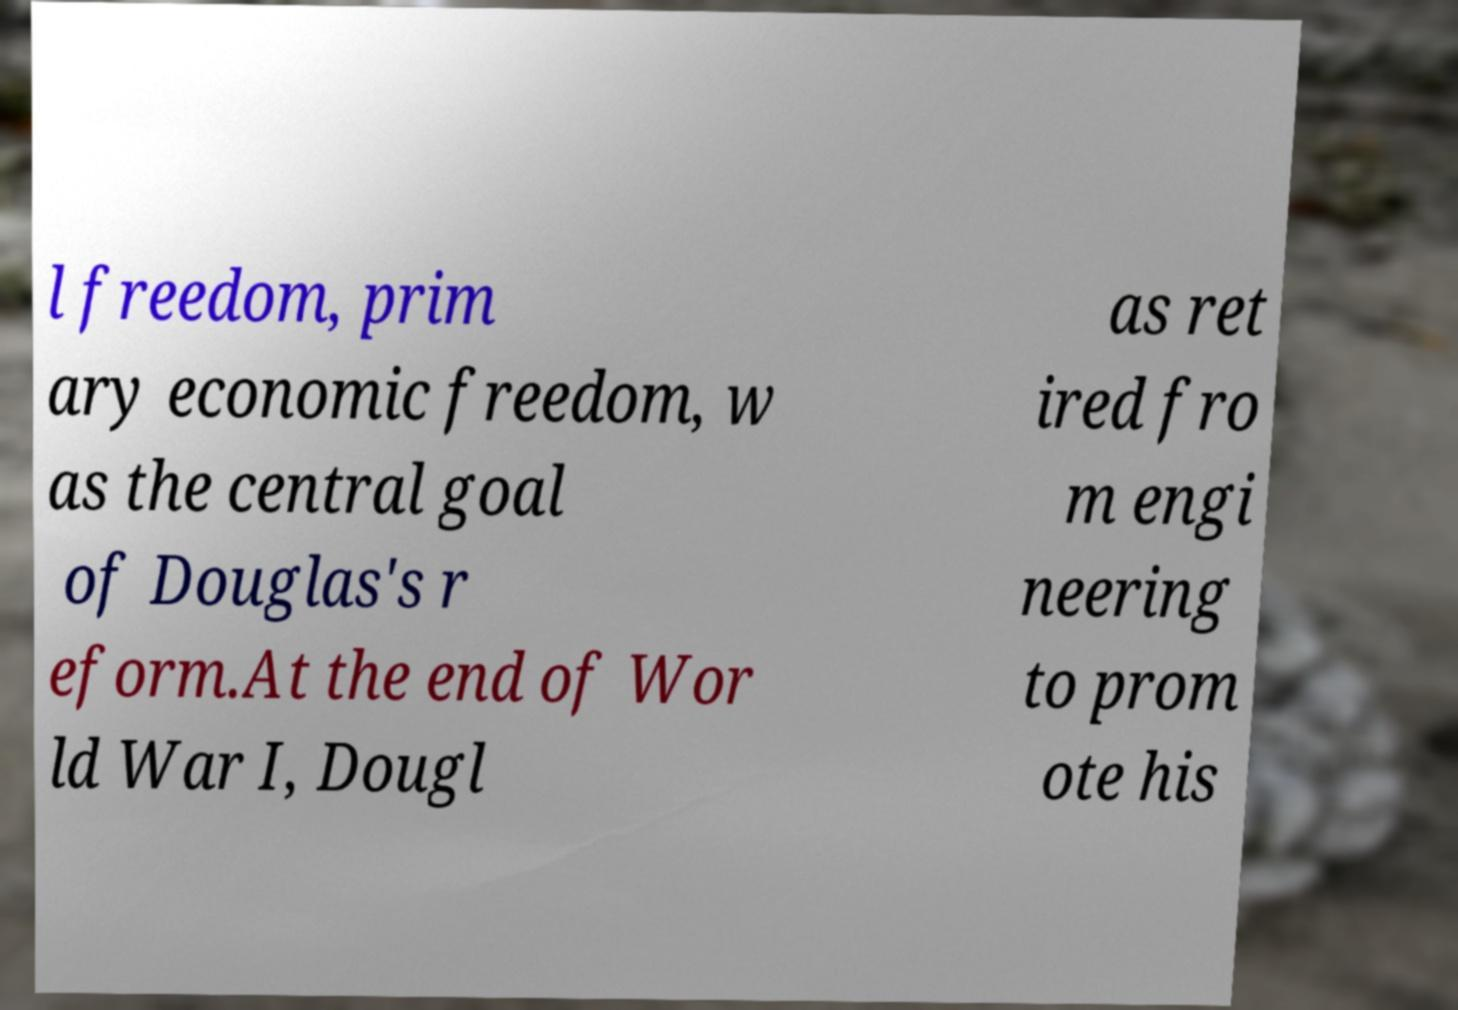There's text embedded in this image that I need extracted. Can you transcribe it verbatim? l freedom, prim ary economic freedom, w as the central goal of Douglas's r eform.At the end of Wor ld War I, Dougl as ret ired fro m engi neering to prom ote his 